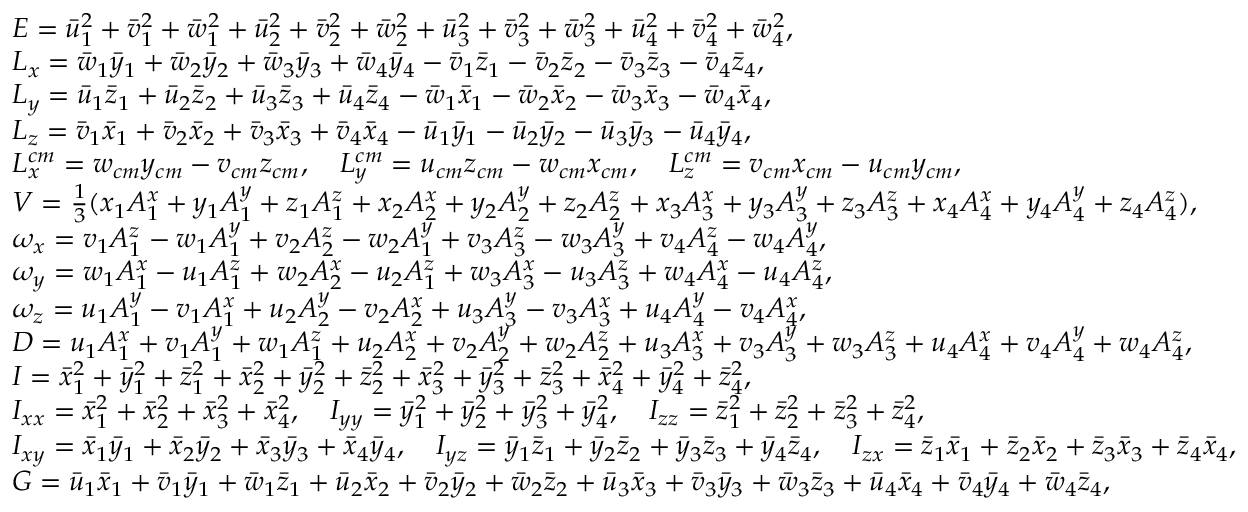<formula> <loc_0><loc_0><loc_500><loc_500>\begin{array} { r l } & { E = \ B a r { u } _ { 1 } ^ { 2 } + \ B a r { v } _ { 1 } ^ { 2 } + \ B a r { w } _ { 1 } ^ { 2 } + \ B a r { u } _ { 2 } ^ { 2 } + \ B a r { v } _ { 2 } ^ { 2 } + \ B a r { w } _ { 2 } ^ { 2 } + \ B a r { u } _ { 3 } ^ { 2 } + \ B a r { v } _ { 3 } ^ { 2 } + \ B a r { w } _ { 3 } ^ { 2 } + \ B a r { u } _ { 4 } ^ { 2 } + \ B a r { v } _ { 4 } ^ { 2 } + \ B a r { w } _ { 4 } ^ { 2 } , } \\ & { L _ { x } = \ B a r { w } _ { 1 } \ B a r { y } _ { 1 } + \ B a r { w } _ { 2 } \ B a r { y } _ { 2 } + \ B a r { w } _ { 3 } \ B a r { y } _ { 3 } + \ B a r { w } _ { 4 } \ B a r { y } _ { 4 } - \ B a r { v } _ { 1 } \ B a r { z } _ { 1 } - \ B a r { v } _ { 2 } \ B a r { z } _ { 2 } - \ B a r { v } _ { 3 } \ B a r { z } _ { 3 } - \ B a r { v } _ { 4 } \ B a r { z } _ { 4 } , } \\ & { L _ { y } = \ B a r { u } _ { 1 } \ B a r { z } _ { 1 } + \ B a r { u } _ { 2 } \ B a r { z } _ { 2 } + \ B a r { u } _ { 3 } \ B a r { z } _ { 3 } + \ B a r { u } _ { 4 } \ B a r { z } _ { 4 } - \ B a r { w } _ { 1 } \ B a r { x } _ { 1 } - \ B a r { w } _ { 2 } \ B a r { x } _ { 2 } - \ B a r { w } _ { 3 } \ B a r { x } _ { 3 } - \ B a r { w } _ { 4 } \ B a r { x } _ { 4 } , } \\ & { L _ { z } = \ B a r { v } _ { 1 } \ B a r { x } _ { 1 } + \ B a r { v } _ { 2 } \ B a r { x } _ { 2 } + \ B a r { v } _ { 3 } \ B a r { x } _ { 3 } + \ B a r { v } _ { 4 } \ B a r { x } _ { 4 } - \ B a r { u } _ { 1 } \ B a r { y } _ { 1 } - \ B a r { u } _ { 2 } \ B a r { y } _ { 2 } - \ B a r { u } _ { 3 } \ B a r { y } _ { 3 } - \ B a r { u } _ { 4 } \ B a r { y } _ { 4 } , } \\ & { L _ { x } ^ { c m } = w _ { c m } y _ { c m } - v _ { c m } z _ { c m } , \quad L _ { y } ^ { c m } = u _ { c m } z _ { c m } - w _ { c m } x _ { c m } , \quad L _ { z } ^ { c m } = v _ { c m } x _ { c m } - u _ { c m } y _ { c m } , } \\ & { V = \frac { 1 } { 3 } ( x _ { 1 } A _ { 1 } ^ { x } + y _ { 1 } A _ { 1 } ^ { y } + z _ { 1 } A _ { 1 } ^ { z } + x _ { 2 } A _ { 2 } ^ { x } + y _ { 2 } A _ { 2 } ^ { y } + z _ { 2 } A _ { 2 } ^ { z } + x _ { 3 } A _ { 3 } ^ { x } + y _ { 3 } A _ { 3 } ^ { y } + z _ { 3 } A _ { 3 } ^ { z } + x _ { 4 } A _ { 4 } ^ { x } + y _ { 4 } A _ { 4 } ^ { y } + z _ { 4 } A _ { 4 } ^ { z } ) , } \\ & { \omega _ { x } = v _ { 1 } A _ { 1 } ^ { z } - w _ { 1 } A _ { 1 } ^ { y } + v _ { 2 } A _ { 2 } ^ { z } - w _ { 2 } A _ { 1 } ^ { y } + v _ { 3 } A _ { 3 } ^ { z } - w _ { 3 } A _ { 3 } ^ { y } + v _ { 4 } A _ { 4 } ^ { z } - w _ { 4 } A _ { 4 } ^ { y } , } \\ & { \omega _ { y } = w _ { 1 } A _ { 1 } ^ { x } - u _ { 1 } A _ { 1 } ^ { z } + w _ { 2 } A _ { 2 } ^ { x } - u _ { 2 } A _ { 1 } ^ { z } + w _ { 3 } A _ { 3 } ^ { x } - u _ { 3 } A _ { 3 } ^ { z } + w _ { 4 } A _ { 4 } ^ { x } - u _ { 4 } A _ { 4 } ^ { z } , } \\ & { \omega _ { z } = u _ { 1 } A _ { 1 } ^ { y } - v _ { 1 } A _ { 1 } ^ { x } + u _ { 2 } A _ { 2 } ^ { y } - v _ { 2 } A _ { 2 } ^ { x } + u _ { 3 } A _ { 3 } ^ { y } - v _ { 3 } A _ { 3 } ^ { x } + u _ { 4 } A _ { 4 } ^ { y } - v _ { 4 } A _ { 4 } ^ { x } , } \\ & { D = u _ { 1 } A _ { 1 } ^ { x } + v _ { 1 } A _ { 1 } ^ { y } + w _ { 1 } A _ { 1 } ^ { z } + u _ { 2 } A _ { 2 } ^ { x } + v _ { 2 } A _ { 2 } ^ { y } + w _ { 2 } A _ { 2 } ^ { z } + u _ { 3 } A _ { 3 } ^ { x } + v _ { 3 } A _ { 3 } ^ { y } + w _ { 3 } A _ { 3 } ^ { z } + u _ { 4 } A _ { 4 } ^ { x } + v _ { 4 } A _ { 4 } ^ { y } + w _ { 4 } A _ { 4 } ^ { z } , } \\ & { I = \ B a r { x } _ { 1 } ^ { 2 } + \ B a r { y } _ { 1 } ^ { 2 } + \ B a r { z } _ { 1 } ^ { 2 } + \ B a r { x } _ { 2 } ^ { 2 } + \ B a r { y } _ { 2 } ^ { 2 } + \ B a r { z } _ { 2 } ^ { 2 } + \ B a r { x } _ { 3 } ^ { 2 } + \ B a r { y } _ { 3 } ^ { 2 } + \ B a r { z } _ { 3 } ^ { 2 } + \ B a r { x } _ { 4 } ^ { 2 } + \ B a r { y } _ { 4 } ^ { 2 } + \ B a r { z } _ { 4 } ^ { 2 } , } \\ & { I _ { x x } = \ B a r { x } _ { 1 } ^ { 2 } + \ B a r { x } _ { 2 } ^ { 2 } + \ B a r { x } _ { 3 } ^ { 2 } + \ B a r { x } _ { 4 } ^ { 2 } , \quad I _ { y y } = \ B a r { y } _ { 1 } ^ { 2 } + \ B a r { y } _ { 2 } ^ { 2 } + \ B a r { y } _ { 3 } ^ { 2 } + \ B a r { y } _ { 4 } ^ { 2 } , \quad I _ { z z } = \ B a r { z } _ { 1 } ^ { 2 } + \ B a r { z } _ { 2 } ^ { 2 } + \ B a r { z } _ { 3 } ^ { 2 } + \ B a r { z } _ { 4 } ^ { 2 } , } \\ & { I _ { x y } = \ B a r { x } _ { 1 } \ B a r { y } _ { 1 } + \ B a r { x } _ { 2 } \ B a r { y } _ { 2 } + \ B a r { x } _ { 3 } \ B a r { y } _ { 3 } + \ B a r { x } _ { 4 } \ B a r { y } _ { 4 } , \quad I _ { y z } = \ B a r { y } _ { 1 } \ B a r { z } _ { 1 } + \ B a r { y } _ { 2 } \ B a r { z } _ { 2 } + \ B a r { y } _ { 3 } \ B a r { z } _ { 3 } + \ B a r { y } _ { 4 } \ B a r { z } _ { 4 } , \quad I _ { z x } = \ B a r { z } _ { 1 } \ B a r { x } _ { 1 } + \ B a r { z } _ { 2 } \ B a r { x } _ { 2 } + \ B a r { z } _ { 3 } \ B a r { x } _ { 3 } + \ B a r { z } _ { 4 } \ B a r { x } _ { 4 } , } \\ & { G = \ B a r { u } _ { 1 } \ B a r { x } _ { 1 } + \ B a r { v } _ { 1 } \ B a r { y } _ { 1 } + \ B a r { w } _ { 1 } \ B a r { z } _ { 1 } + \ B a r { u } _ { 2 } \ B a r { x } _ { 2 } + \ B a r { v } _ { 2 } \ B a r { y } _ { 2 } + \ B a r { w } _ { 2 } \ B a r { z } _ { 2 } + \ B a r { u } _ { 3 } \ B a r { x } _ { 3 } + \ B a r { v } _ { 3 } \ B a r { y } _ { 3 } + \ B a r { w } _ { 3 } \ B a r { z } _ { 3 } + \ B a r { u } _ { 4 } \ B a r { x } _ { 4 } + \ B a r { v } _ { 4 } \ B a r { y } _ { 4 } + \ B a r { w } _ { 4 } \ B a r { z } _ { 4 } , } \end{array}</formula> 